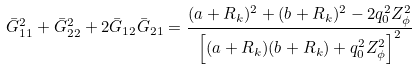<formula> <loc_0><loc_0><loc_500><loc_500>\bar { G } ^ { 2 } _ { 1 1 } + \bar { G } ^ { 2 } _ { 2 2 } + 2 \bar { G } _ { 1 2 } \bar { G } _ { 2 1 } = \frac { ( a + R _ { k } ) ^ { 2 } + ( b + R _ { k } ) ^ { 2 } - 2 q ^ { 2 } _ { 0 } Z _ { \phi } ^ { 2 } } { \left [ ( a + R _ { k } ) ( b + R _ { k } ) + q ^ { 2 } _ { 0 } Z _ { \phi } ^ { 2 } \right ] ^ { 2 } }</formula> 